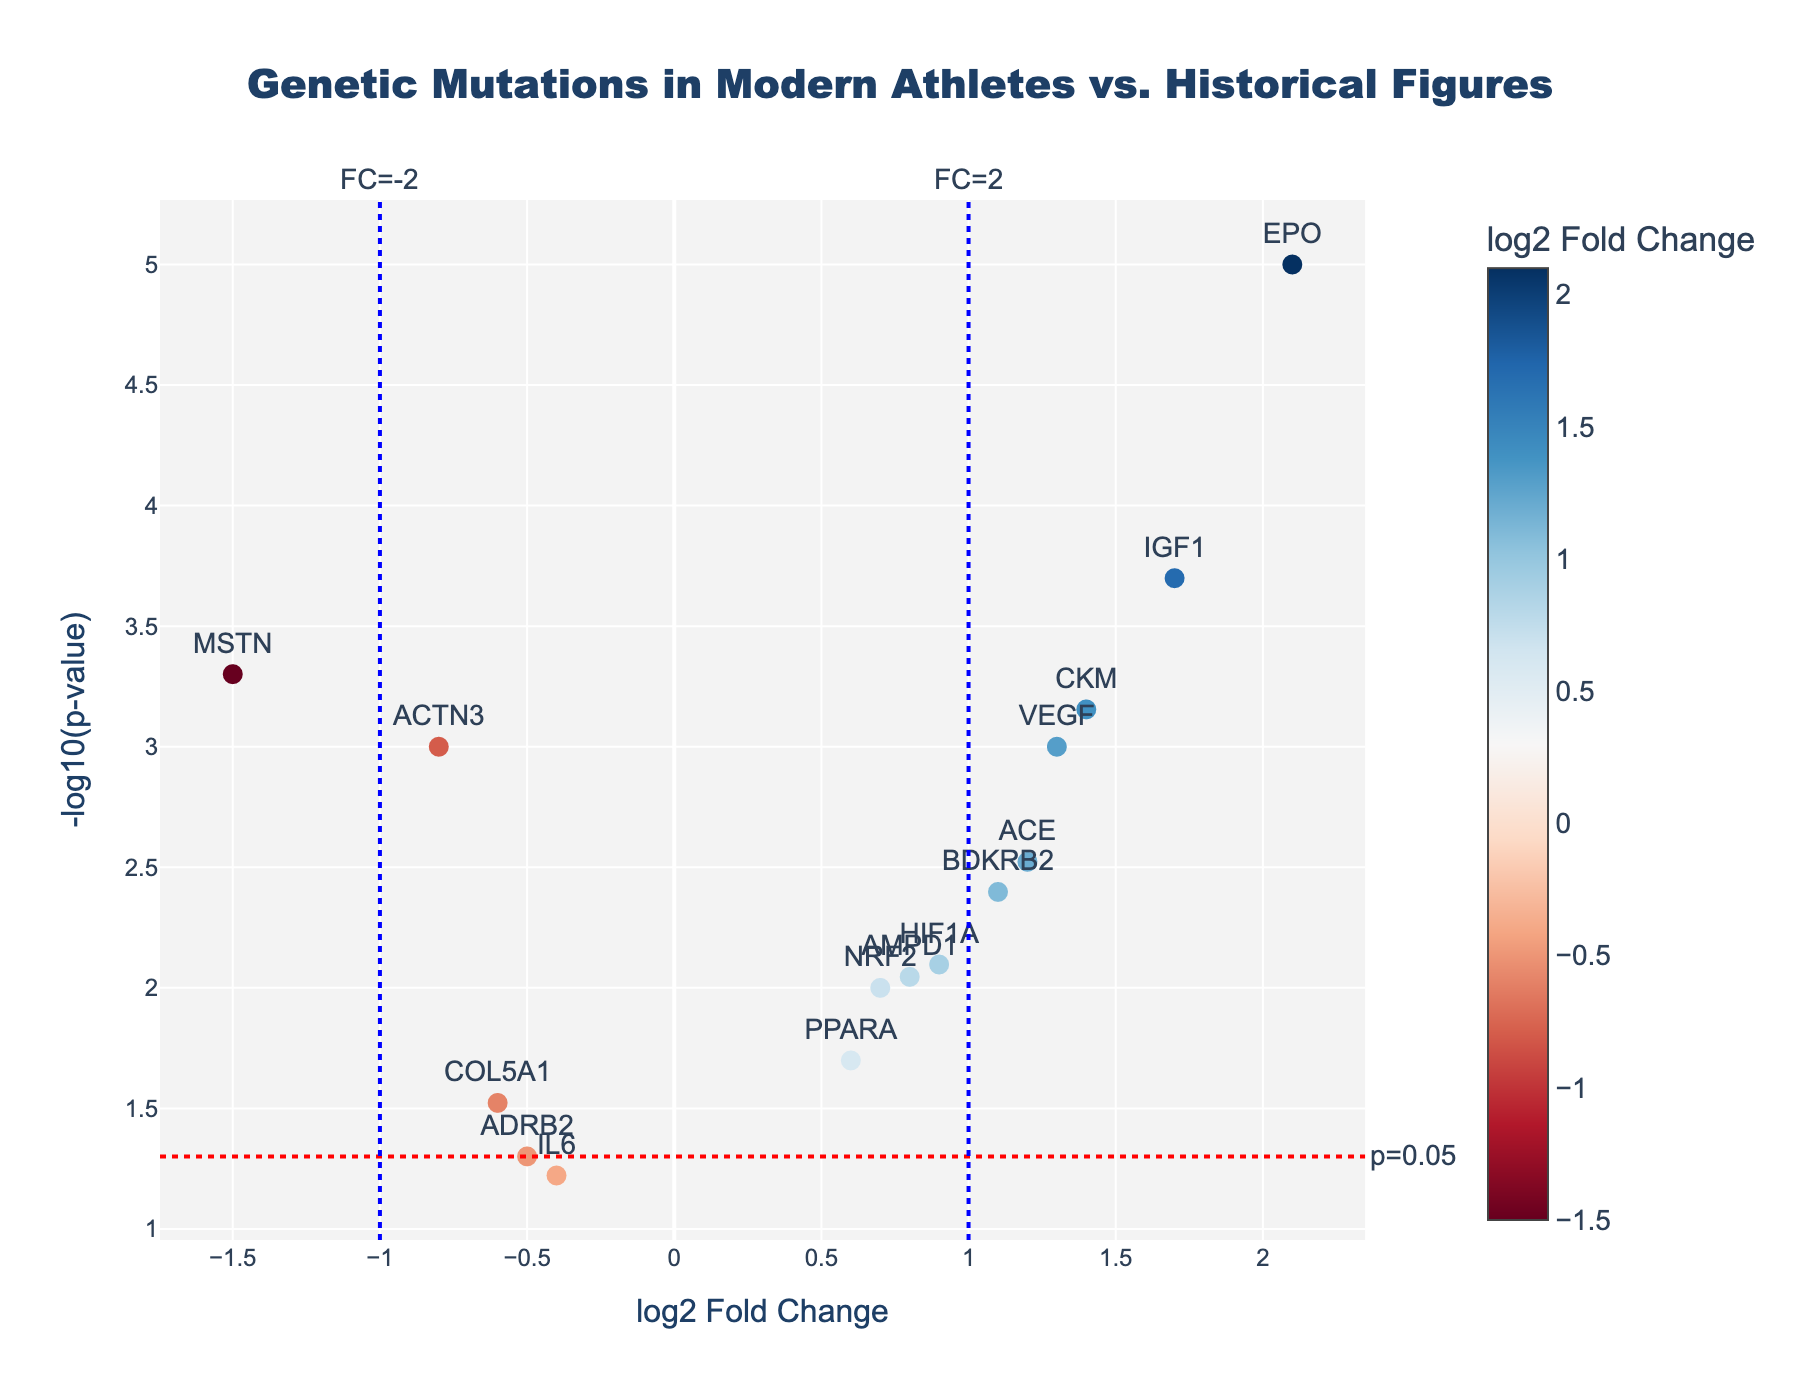What is the title of the figure? The title of the figure is displayed at the top. Reading it directly reveals that it is "Genetic Mutations in Modern Athletes vs. Historical Figures."
Answer: Genetic Mutations in Modern Athletes vs. Historical Figures What does the x-axis represent? The x-axis shows the "log2 Fold Change" for different genes. Reading the label on the horizontal axis confirms this.
Answer: log2 Fold Change What does the y-axis represent? The y-axis represents the "-log10(p-value)" of different genes. Reading the label on the vertical axis confirms this.
Answer: -log10(p-value) Which gene has the highest log2 Fold Change? By examining the plot, the EPO gene has the highest log2 Fold Change at 2.1.
Answer: EPO Which gene has the lowest p-value? The gene with the lowest p-value will have the highest -log10(p-value). By observing the plot, the EPO gene appears at the highest y-axis value, indicating it has the lowest p-value.
Answer: EPO How many genes have a log2 Fold Change between -1 and 1? To find this, look for genes that fall within the vertical lines at -1 and 1 on the x-axis. These genes are ACTN3, PPARA, MSTN, HIF1A, NRF2, AMPD1, IL6, and COL5A1. Counting these genes gives 8.
Answer: 8 What is the log2 Fold Change for the MSTN gene? Locate the MSTN gene on the plot, it corresponds to a log2 Fold Change of -1.5, as shown on the x-axis.
Answer: -1.5 Which genes have a p-value less than 0.05? Genes with a p-value less than 0.05 appear above the horizontal red dotted line (which denotes -log10(0.05)). They are ACTN3, ACE, MSTN, EPO, HIF1A, IGF1, VEGF, BDKRB2, and CKM.
Answer: ACTN3, ACE, MSTN, EPO, HIF1A, IGF1, VEGF, BDKRB2, CKM Among the listed genes, which one is the most upregulated in modern athletes compared to historical figures? Upregulation is indicated by a positive log2 Fold Change. The gene with the highest positive value on the x-axis is EPO with a log2 Fold Change of 2.1.
Answer: EPO Count the number of genes that exhibit a negative log2 Fold Change but are statistically significant (p-value < 0.05). Identify genes with a negative log2 Fold Change (left side of the plot) that are also above the red dotted line (indicating p < 0.05). These genes are ACTN3 and MSTN, hence there are 2 such genes.
Answer: 2 